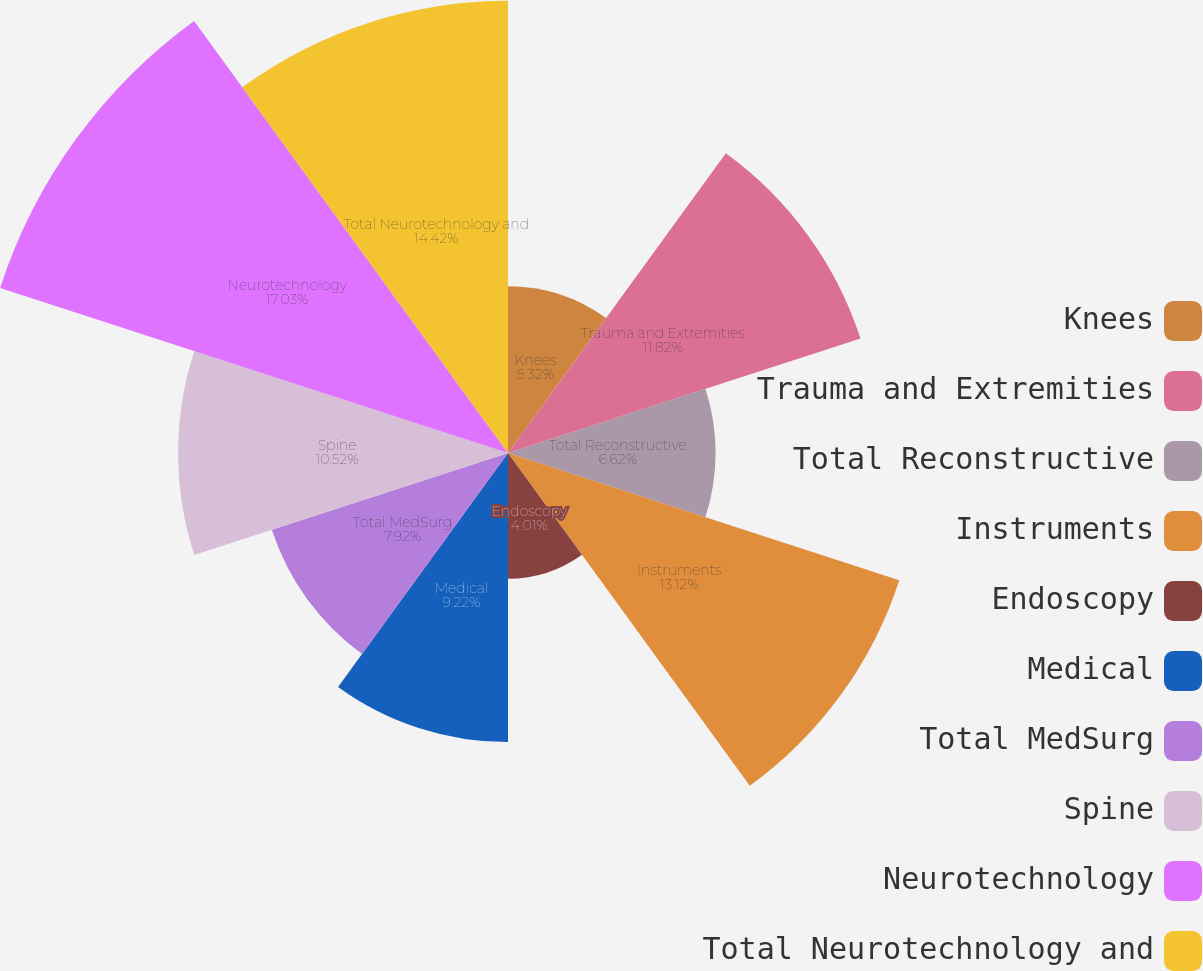Convert chart to OTSL. <chart><loc_0><loc_0><loc_500><loc_500><pie_chart><fcel>Knees<fcel>Trauma and Extremities<fcel>Total Reconstructive<fcel>Instruments<fcel>Endoscopy<fcel>Medical<fcel>Total MedSurg<fcel>Spine<fcel>Neurotechnology<fcel>Total Neurotechnology and<nl><fcel>5.32%<fcel>11.82%<fcel>6.62%<fcel>13.12%<fcel>4.01%<fcel>9.22%<fcel>7.92%<fcel>10.52%<fcel>17.03%<fcel>14.42%<nl></chart> 